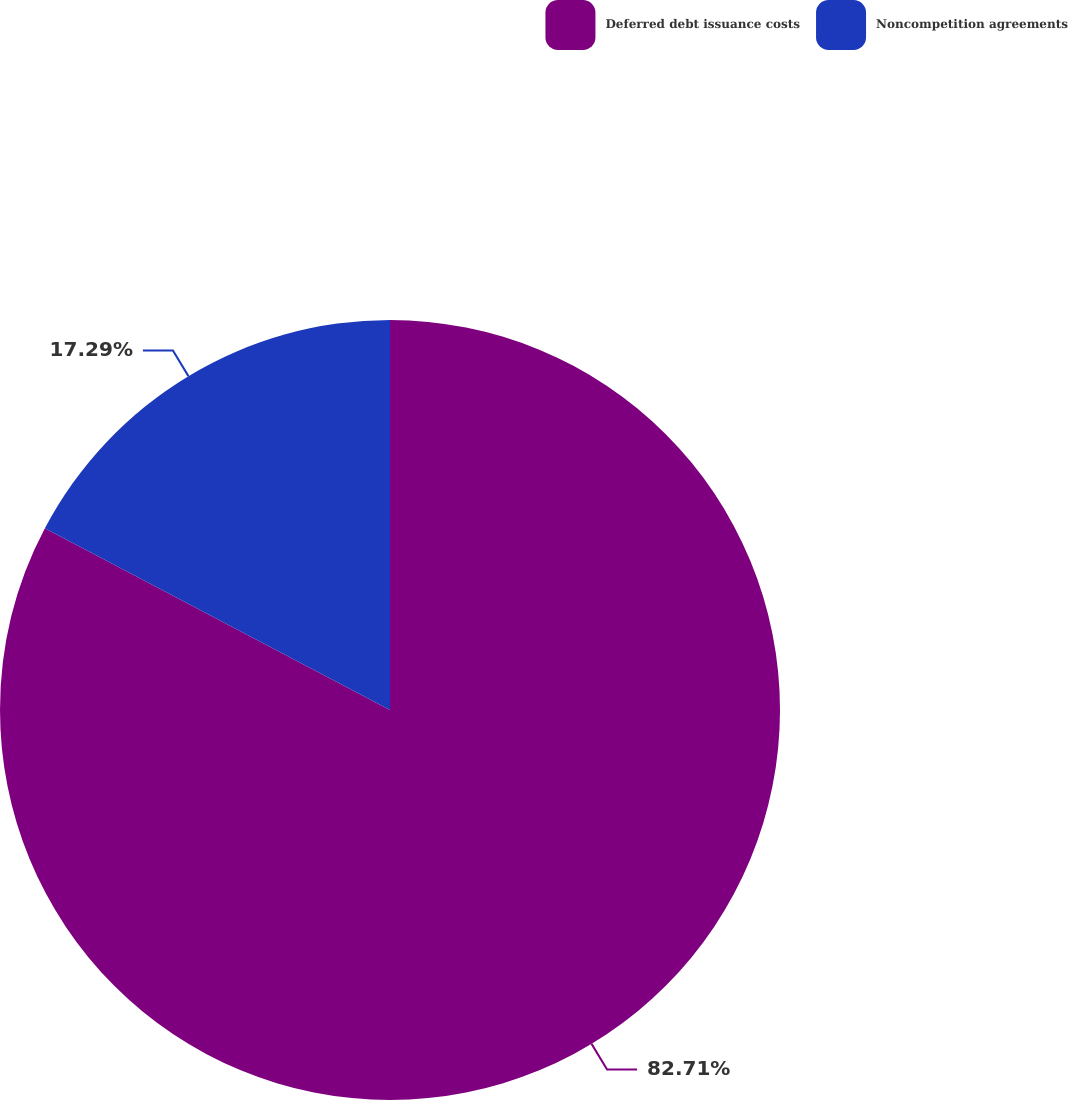Convert chart to OTSL. <chart><loc_0><loc_0><loc_500><loc_500><pie_chart><fcel>Deferred debt issuance costs<fcel>Noncompetition agreements<nl><fcel>82.71%<fcel>17.29%<nl></chart> 